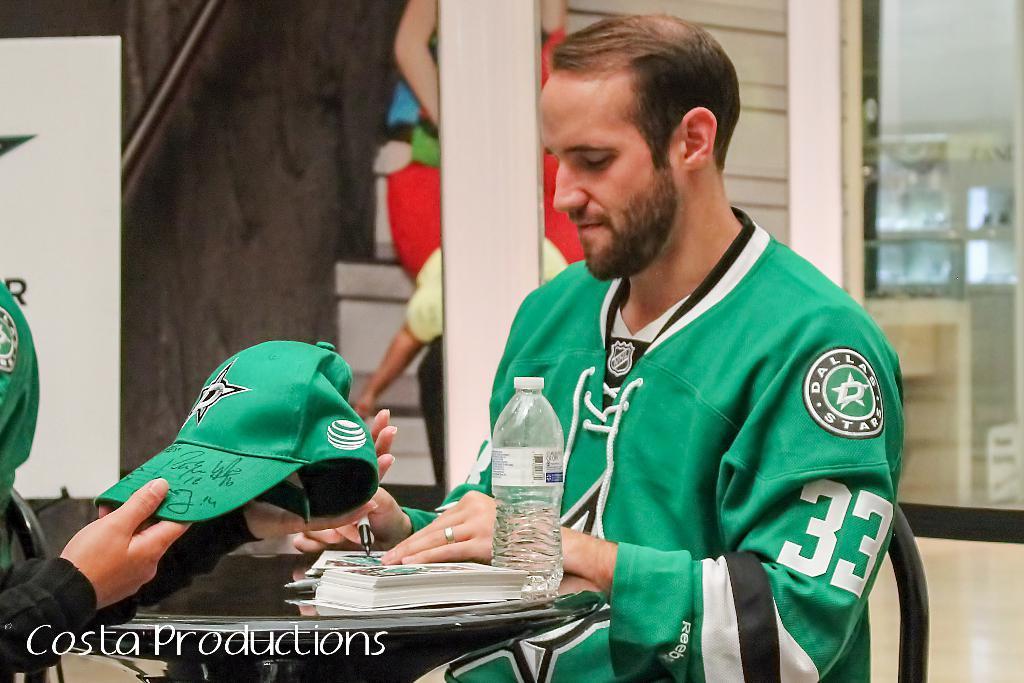Describe this image in one or two sentences. In this image at front there are two persons sitting on the chairs. In front of them there is a table. On top of the table there are cards, water bottle. Behind them there are stairs. At the back side there is a door. 